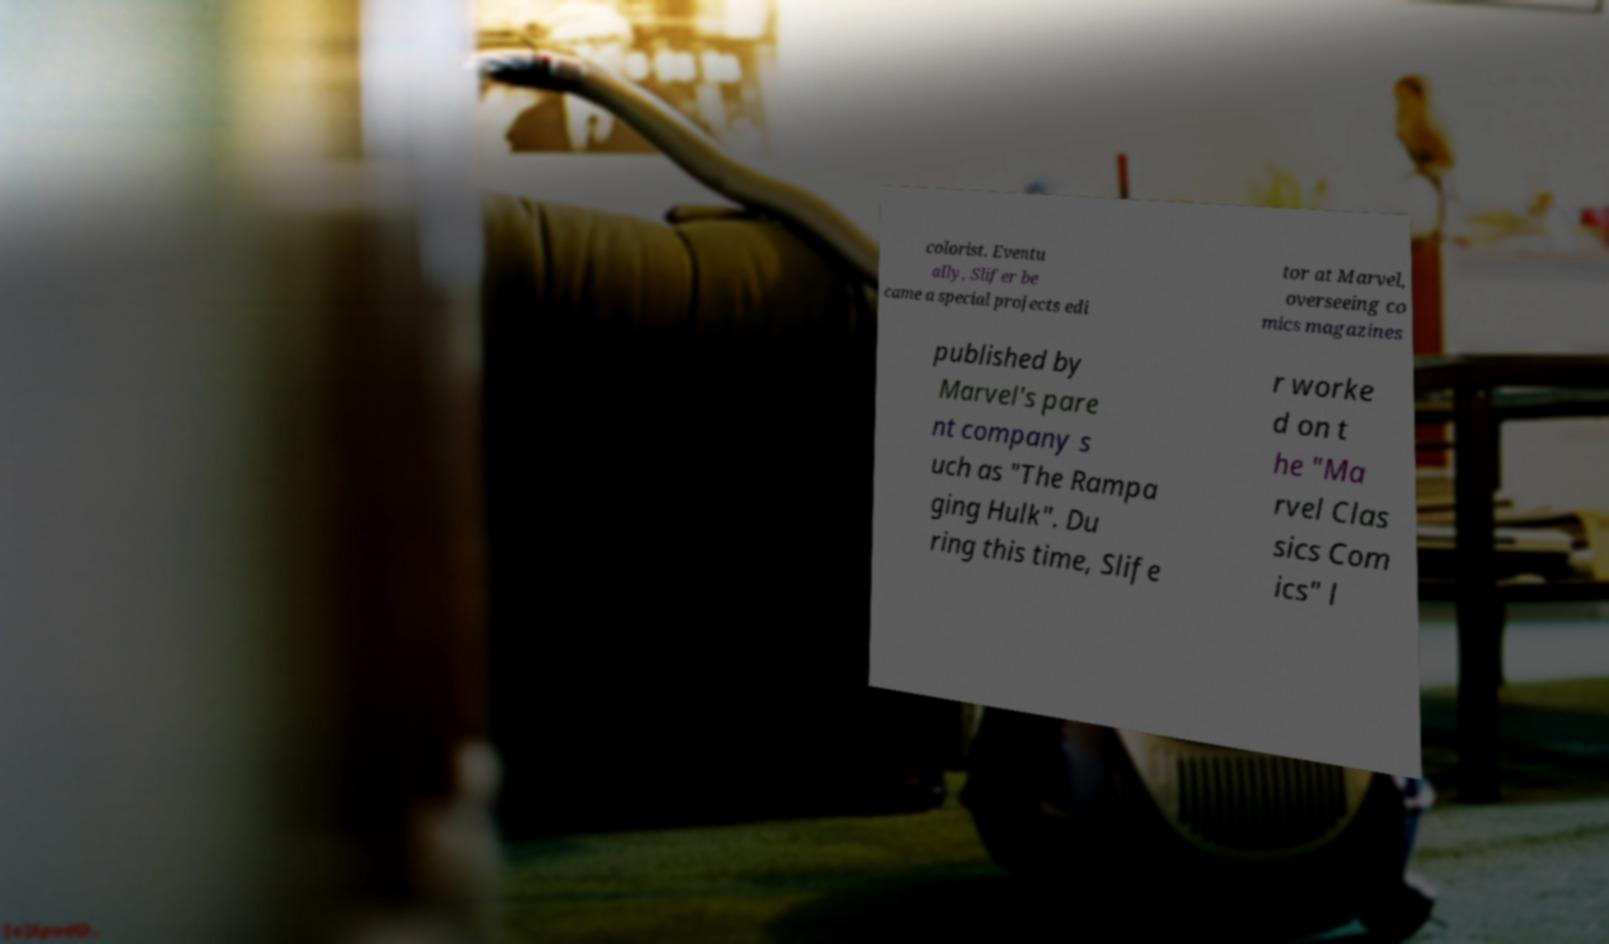Please read and relay the text visible in this image. What does it say? colorist. Eventu ally, Slifer be came a special projects edi tor at Marvel, overseeing co mics magazines published by Marvel's pare nt company s uch as "The Rampa ging Hulk". Du ring this time, Slife r worke d on t he "Ma rvel Clas sics Com ics" l 